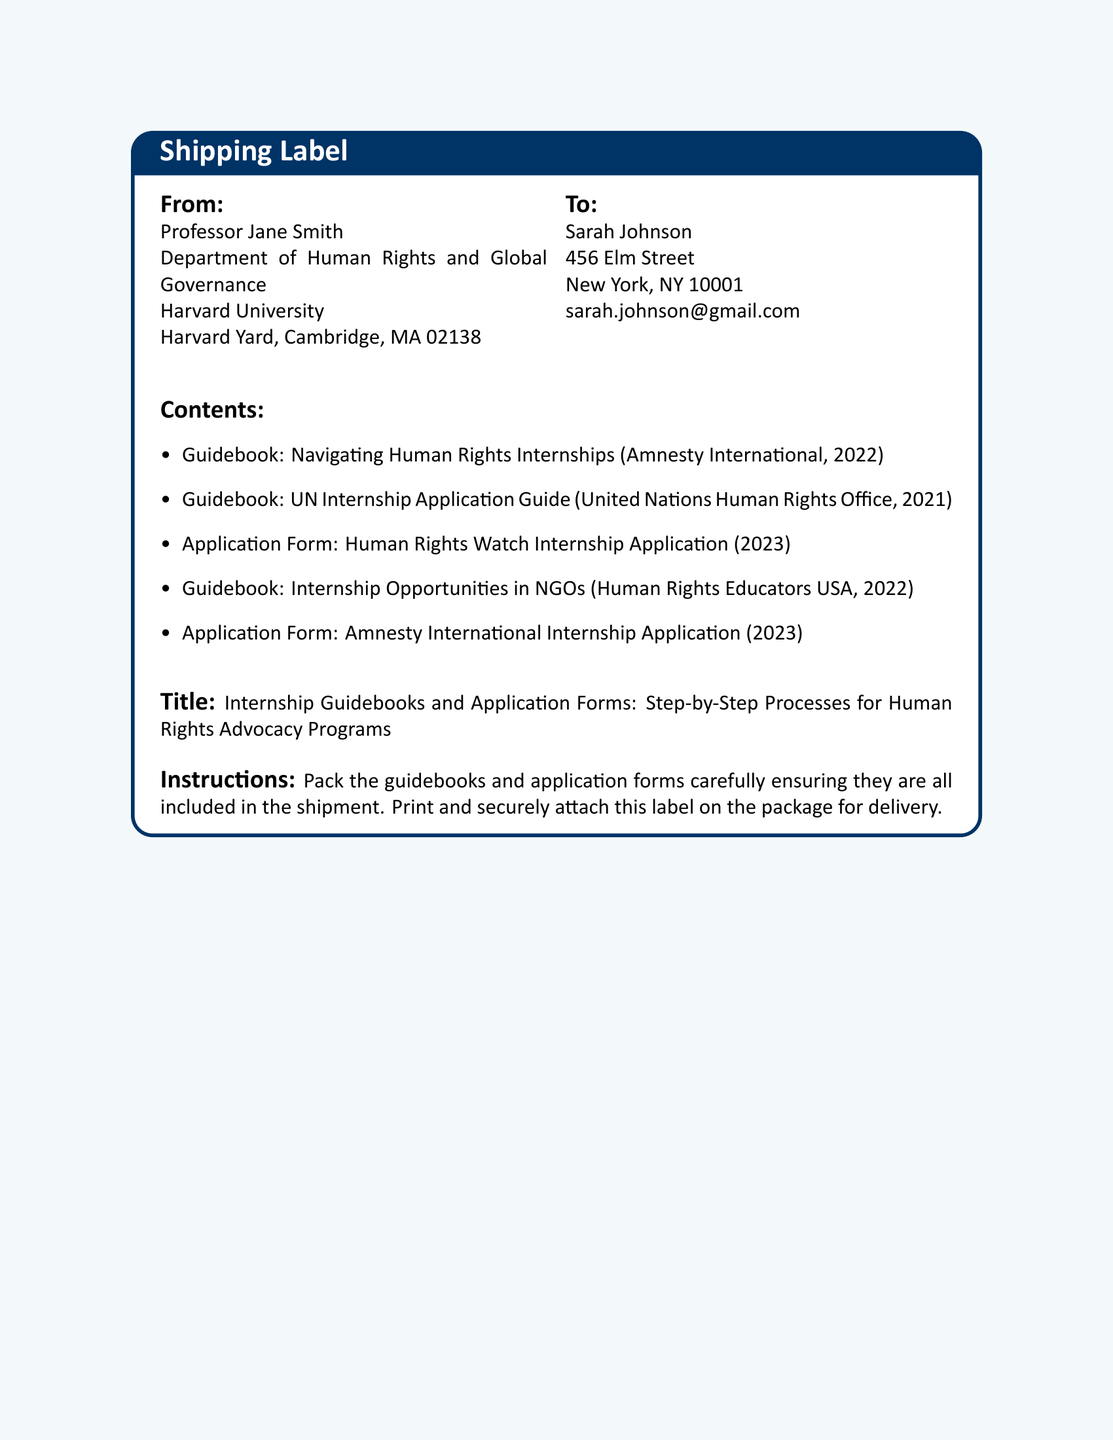What is the sender's name? The sender's name is listed in the "From" section of the document, which is Professor Jane Smith.
Answer: Professor Jane Smith What is the recipient's email? The recipient's email is provided in the "To" section, which shows the contact information for Sarah Johnson.
Answer: sarah.johnson@gmail.com What year was the UN Internship Application Guide published? The document lists the publication year of the UN Internship Application Guide, which is 2021.
Answer: 2021 How many application forms are included in the contents? The number of application forms can be counted from the itemized list under "Contents." There are two application forms listed.
Answer: 2 What is the title of the document? The title is clearly stated in the document, which is related to internship guidebooks and application forms.
Answer: Internship Guidebooks and Application Forms: Step-by-Step Processes for Human Rights Advocacy Programs Who is responsible for the shipment? The instructions indicate the person coordinating the shipping, which is Professor Jane Smith.
Answer: Professor Jane Smith What color is the shipping label's background? The background color of the shipping label is provided in the document layout's specifications.
Answer: light blue What is one of the organizations mentioned in the guidebooks? The list of contents includes various organizations; one of them is Amnesty International.
Answer: Amnesty International What type of document is this? The overall structure and purpose of the document indicate that it belongs to a specific category related to shipping and labels.
Answer: Shipping label 